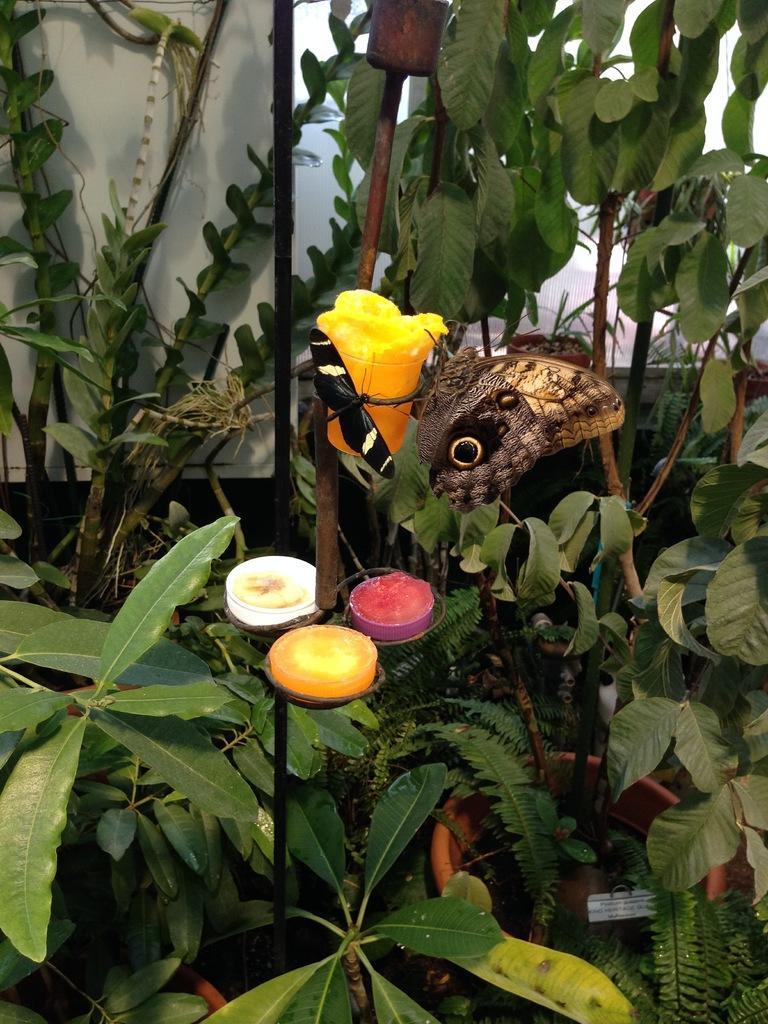How would you summarize this image in a sentence or two? In this picture, we can see two butterflies on the object, and we can see some plants and white background. 